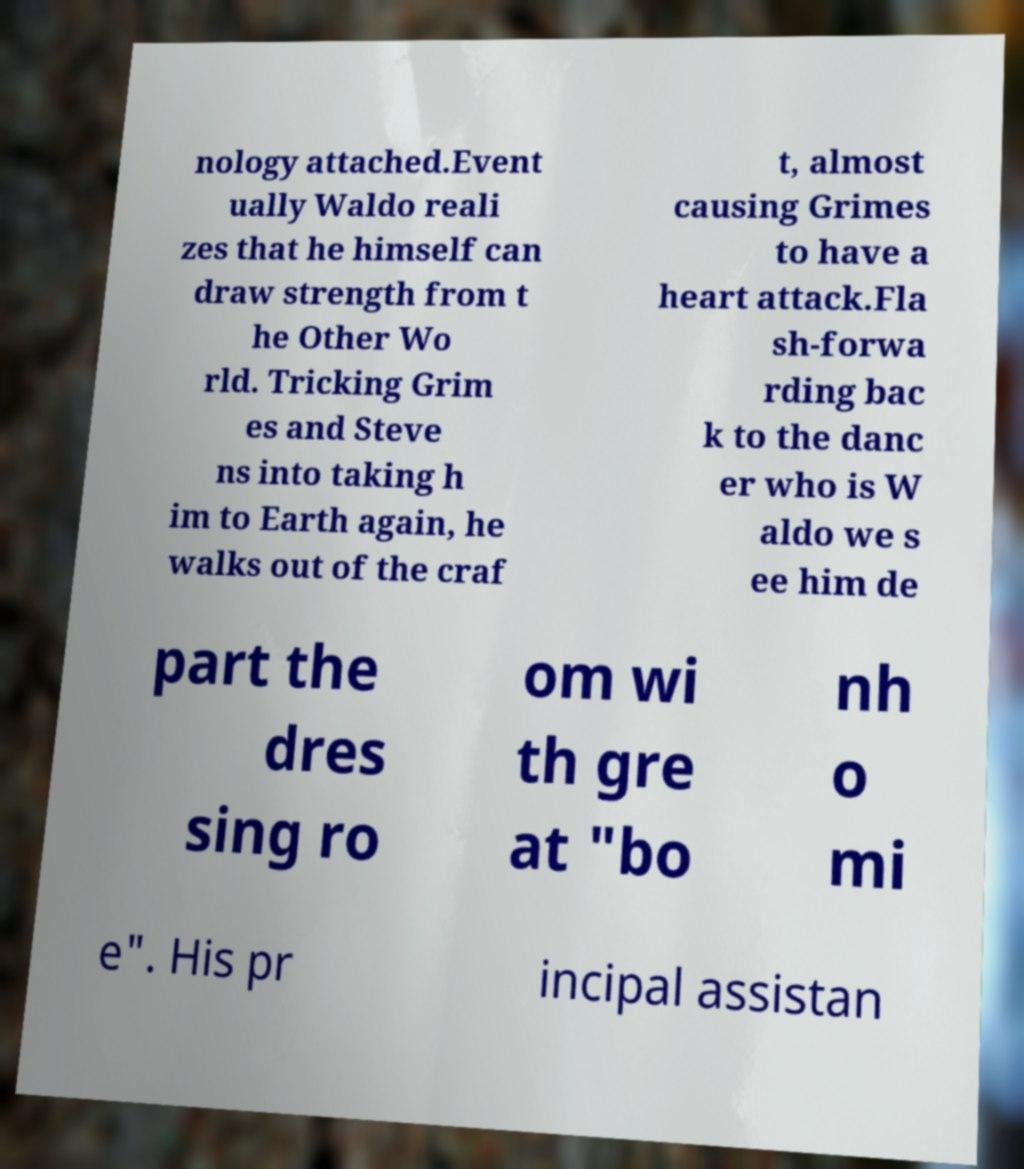Can you read and provide the text displayed in the image?This photo seems to have some interesting text. Can you extract and type it out for me? nology attached.Event ually Waldo reali zes that he himself can draw strength from t he Other Wo rld. Tricking Grim es and Steve ns into taking h im to Earth again, he walks out of the craf t, almost causing Grimes to have a heart attack.Fla sh-forwa rding bac k to the danc er who is W aldo we s ee him de part the dres sing ro om wi th gre at "bo nh o mi e". His pr incipal assistan 